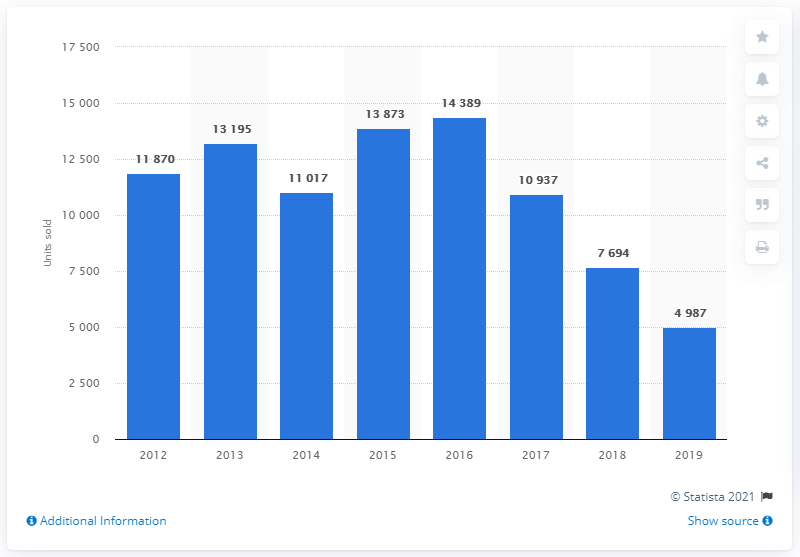Identify some key points in this picture. In 2016, Kia automobiles sold a record-breaking 14,389 vehicles in Turkey, making it the company's most successful year in the country to date. In 2019, a total of 14,389 Kia cars were sold in Turkey. Kia began selling cars in Turkey in the year 2012. 